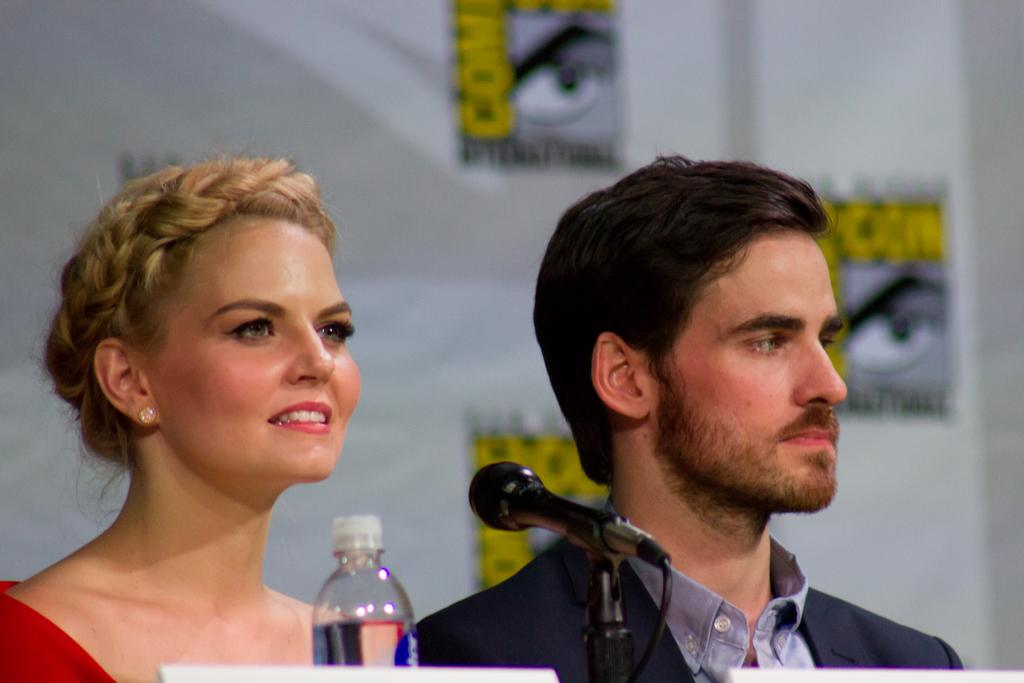Who are the people in the image? There is a man and a woman in the image. What objects are present in front of them? A microphone and a water bottle are present in front of them. What event might they be attending, based on the banner in the background? They might be attending a Comic Con event, as there is a banner of comic con in the background. What type of rose is the man holding in the image? There is no rose present in the image; the man is not holding any object. 